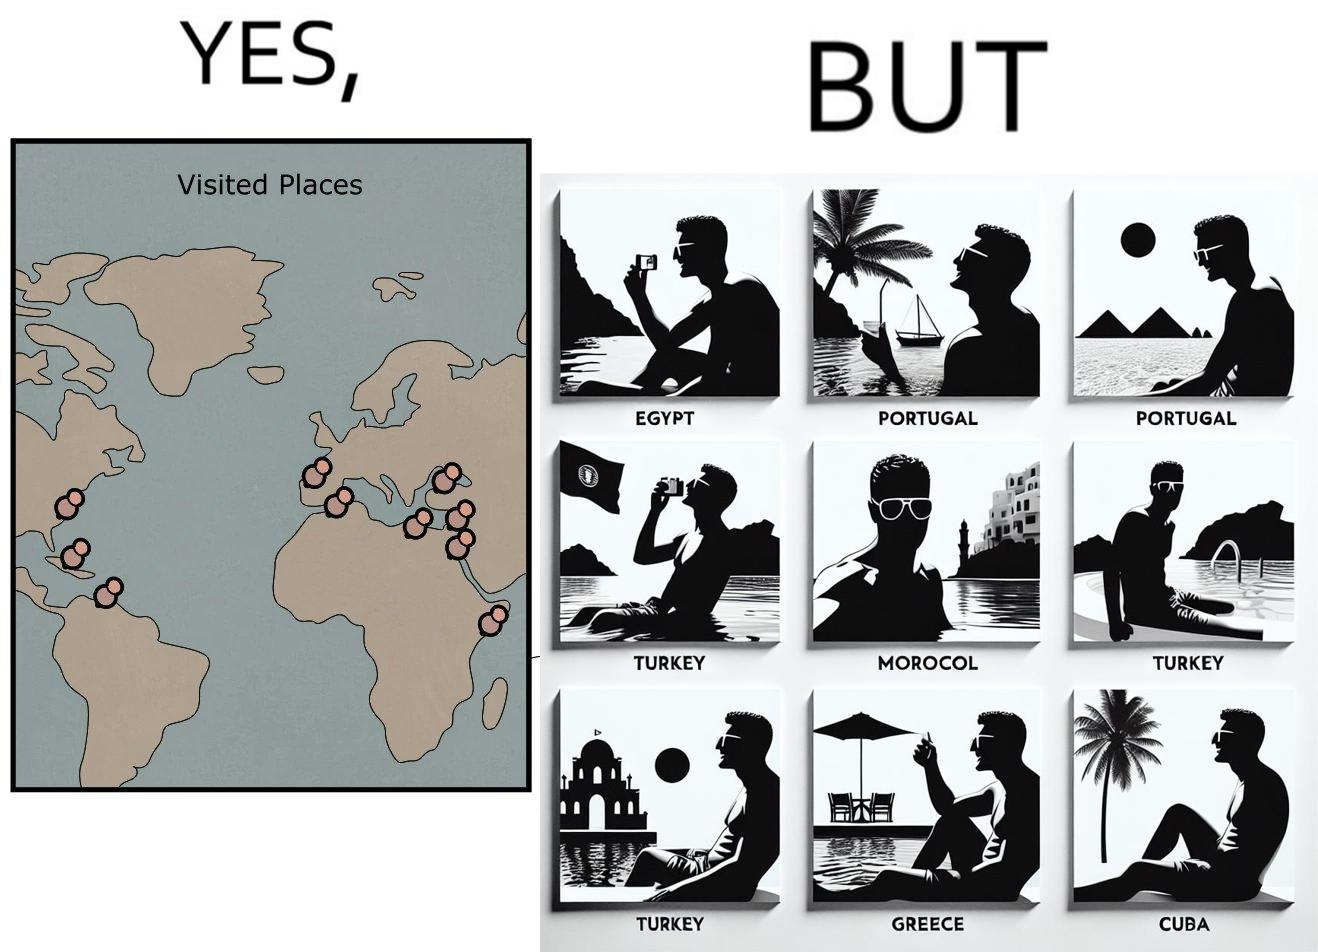Is there satirical content in this image? Yes, this image is satirical. 